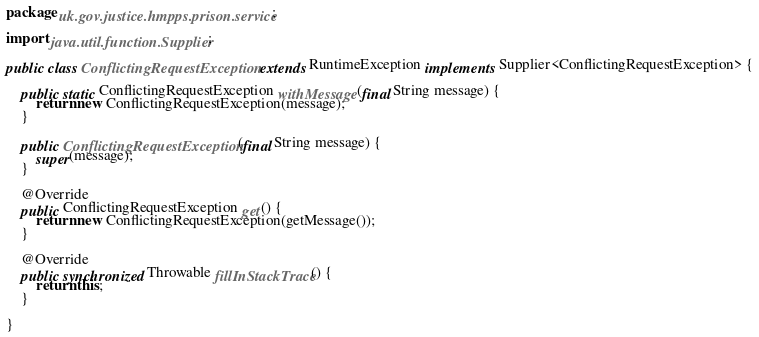<code> <loc_0><loc_0><loc_500><loc_500><_Java_>package uk.gov.justice.hmpps.prison.service;

import java.util.function.Supplier;

public class ConflictingRequestException extends RuntimeException implements Supplier<ConflictingRequestException> {

    public static ConflictingRequestException withMessage(final String message) {
        return new ConflictingRequestException(message);
    }

    public ConflictingRequestException(final String message) {
        super(message);
    }

    @Override
    public ConflictingRequestException get() {
        return new ConflictingRequestException(getMessage());
    }

    @Override
    public synchronized Throwable fillInStackTrace() {
        return this;
    }

}
</code> 